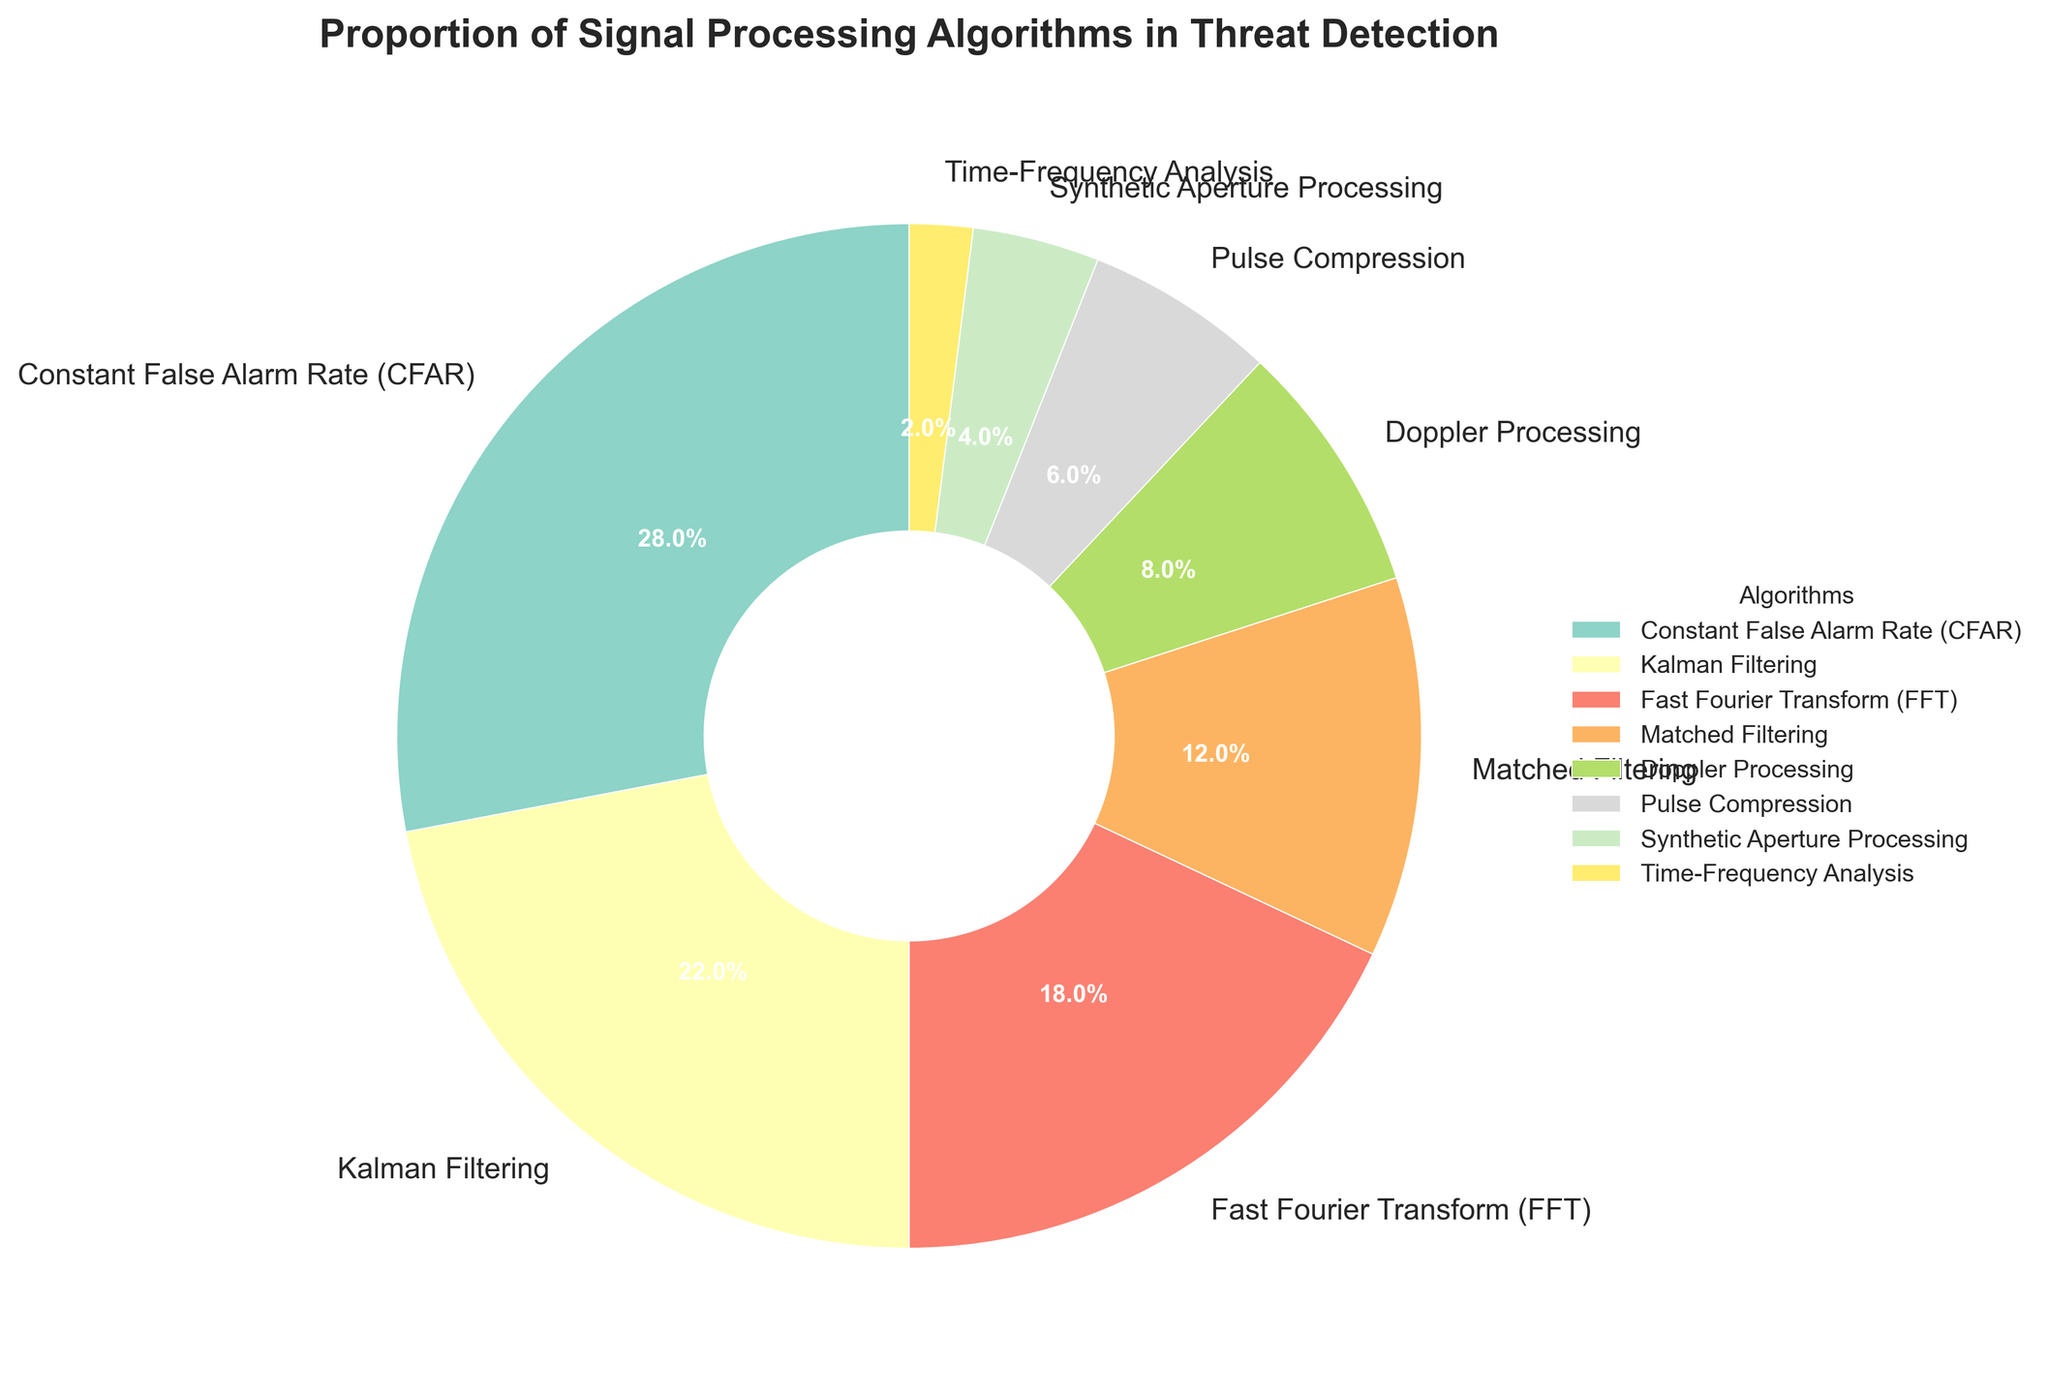Which algorithm has the highest proportion in the pie chart? The pie chart displays several wedges each representing a different algorithm, with the percentages displayed on each wedge. The largest wedge by percentage is "Constant False Alarm Rate (CFAR)" with 28%.
Answer: Constant False Alarm Rate (CFAR) Which two algorithms together make up the smallest proportion? The pie chart indicates each algorithm's proportion of the whole. By checking each percentage, we observe that "Time-Frequency Analysis" at 2% and "Synthetic Aperture Processing" at 4% together have the smallest combined proportion, summing to 6%.
Answer: Time-Frequency Analysis and Synthetic Aperture Processing What is the combined percentage of Fast Fourier Transform (FFT), Doppler Processing, and Pulse Compression? We sum the percentage values of the three algorithms: Fast Fourier Transform (FFT) at 18%, Doppler Processing at 8%, and Pulse Compression at 6%. Therefore, the combined percentage is 18% + 8% + 6% = 32%.
Answer: 32% Which algorithm's slice is visually the closest in size to Kalman Filtering? To determine this, we compare the percentages displayed on the wedges. Kalman Filtering is 22%, and the nearest in proportion visually is Fast Fourier Transform (FFT) at 18%.
Answer: Fast Fourier Transform (FFT) What percentage of the pie chart is not covered by CFAR and Kalman Filtering together? First, we add the percentages of CFAR (28%) and Kalman Filtering (22%) which totals to 50%. The remaining percentage thus is 100% - 50% = 50%.
Answer: 50% What is the percentage difference between the largest and smallest algorithm proportions? The largest proportion is CFAR at 28%, and the smallest is Time-Frequency Analysis at 2%. The difference is 28% - 2% = 26%.
Answer: 26% How does the size of the slice representing Matched Filtering compare to the combined slices of Pulse Compression and Doppler Processing? The pie chart shows Matched Filtering with 12%, Pulse Compression with 6%, and Doppler Processing with 8%. Adding Pulse Compression and Doppler Processing percentages gives us 6% + 8% = 14%, which is larger than Matched Filtering’s 12%.
Answer: The combined slices of Pulse Compression and Doppler Processing are larger What two algorithms together account for approximately one-third of the pie chart? A third of the pie chart is approximately 33.33%. Summing the percentages of different combinations, we find that FFT (18%) and Kalman Filtering (22%) together account for 18% + 22% = 40%, which doesn't fit. However, CFAR (28%) and Pulse Compression (6%) account for 28% + 6% = 34%, which is closest to one-third.
Answer: CFAR and Pulse Compression 